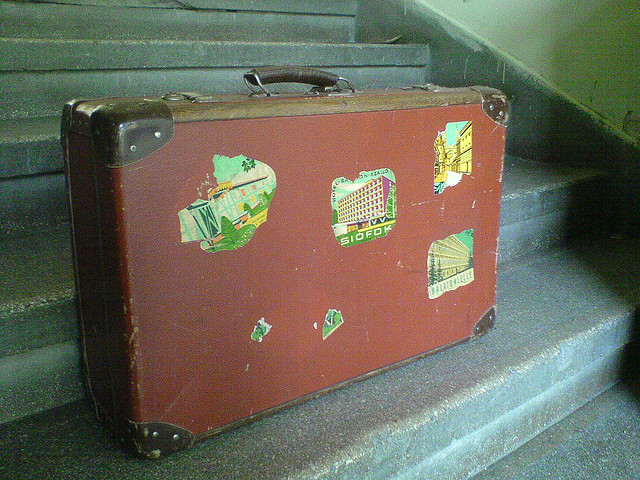<image>How old are the steps? It is unknown how old the steps are. They could be very old or fairly new. How old are the steps? I am not sure how old the steps are. They can be very old, about 20 years old, or even 100 years old. 